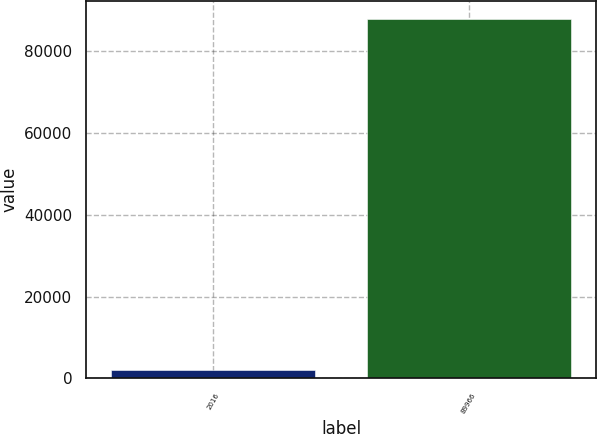<chart> <loc_0><loc_0><loc_500><loc_500><bar_chart><fcel>2016<fcel>89966<nl><fcel>2015<fcel>87973<nl></chart> 